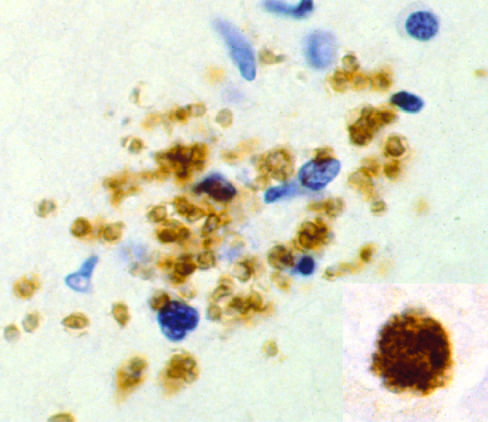what are demonstrated by immunohistochemical staining?
Answer the question using a single word or phrase. Free tachyzoites 